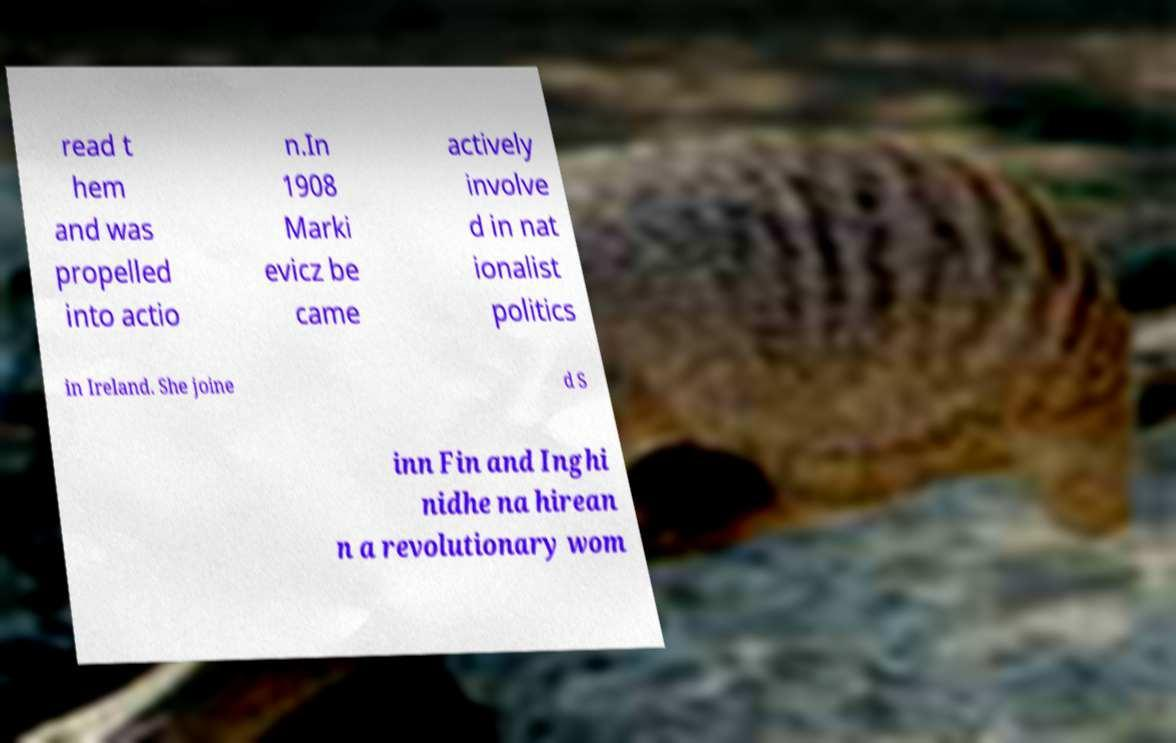What messages or text are displayed in this image? I need them in a readable, typed format. read t hem and was propelled into actio n.In 1908 Marki evicz be came actively involve d in nat ionalist politics in Ireland. She joine d S inn Fin and Inghi nidhe na hirean n a revolutionary wom 